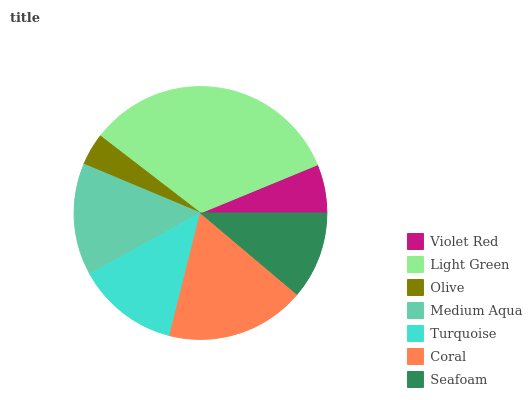Is Olive the minimum?
Answer yes or no. Yes. Is Light Green the maximum?
Answer yes or no. Yes. Is Light Green the minimum?
Answer yes or no. No. Is Olive the maximum?
Answer yes or no. No. Is Light Green greater than Olive?
Answer yes or no. Yes. Is Olive less than Light Green?
Answer yes or no. Yes. Is Olive greater than Light Green?
Answer yes or no. No. Is Light Green less than Olive?
Answer yes or no. No. Is Turquoise the high median?
Answer yes or no. Yes. Is Turquoise the low median?
Answer yes or no. Yes. Is Olive the high median?
Answer yes or no. No. Is Medium Aqua the low median?
Answer yes or no. No. 